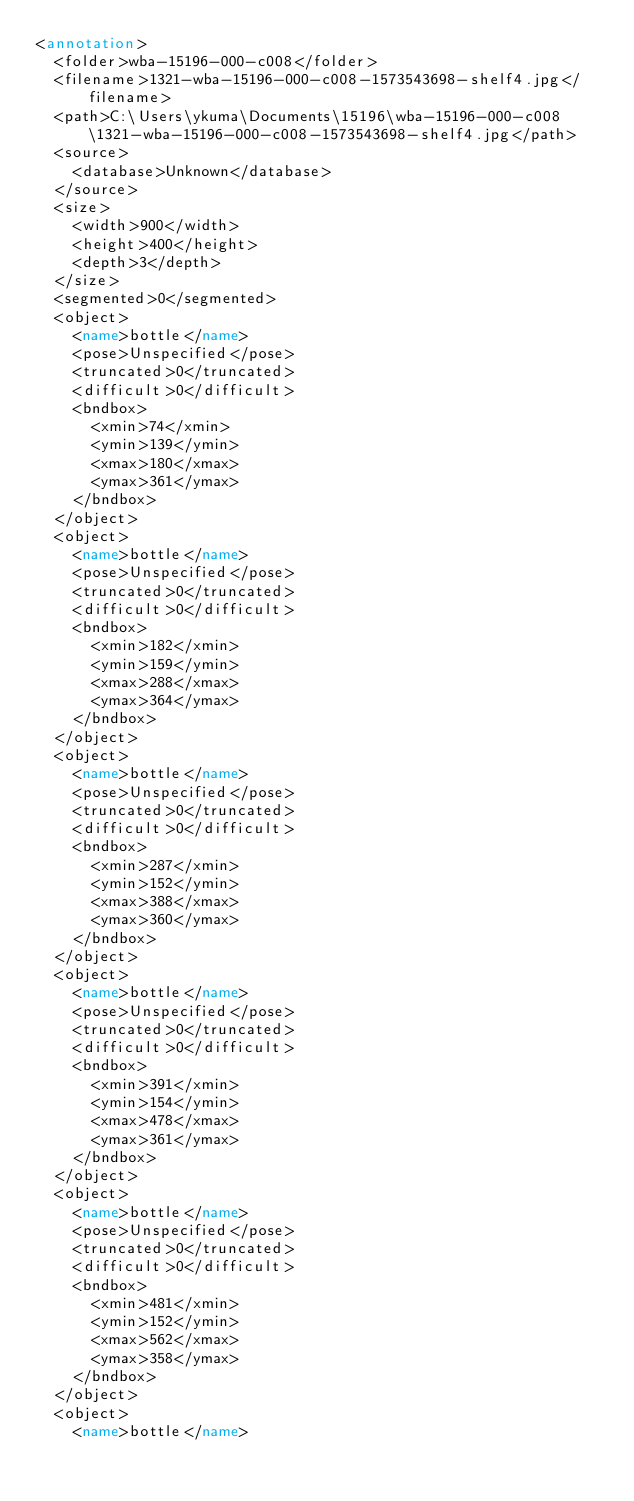Convert code to text. <code><loc_0><loc_0><loc_500><loc_500><_XML_><annotation>
	<folder>wba-15196-000-c008</folder>
	<filename>1321-wba-15196-000-c008-1573543698-shelf4.jpg</filename>
	<path>C:\Users\ykuma\Documents\15196\wba-15196-000-c008\1321-wba-15196-000-c008-1573543698-shelf4.jpg</path>
	<source>
		<database>Unknown</database>
	</source>
	<size>
		<width>900</width>
		<height>400</height>
		<depth>3</depth>
	</size>
	<segmented>0</segmented>
	<object>
		<name>bottle</name>
		<pose>Unspecified</pose>
		<truncated>0</truncated>
		<difficult>0</difficult>
		<bndbox>
			<xmin>74</xmin>
			<ymin>139</ymin>
			<xmax>180</xmax>
			<ymax>361</ymax>
		</bndbox>
	</object>
	<object>
		<name>bottle</name>
		<pose>Unspecified</pose>
		<truncated>0</truncated>
		<difficult>0</difficult>
		<bndbox>
			<xmin>182</xmin>
			<ymin>159</ymin>
			<xmax>288</xmax>
			<ymax>364</ymax>
		</bndbox>
	</object>
	<object>
		<name>bottle</name>
		<pose>Unspecified</pose>
		<truncated>0</truncated>
		<difficult>0</difficult>
		<bndbox>
			<xmin>287</xmin>
			<ymin>152</ymin>
			<xmax>388</xmax>
			<ymax>360</ymax>
		</bndbox>
	</object>
	<object>
		<name>bottle</name>
		<pose>Unspecified</pose>
		<truncated>0</truncated>
		<difficult>0</difficult>
		<bndbox>
			<xmin>391</xmin>
			<ymin>154</ymin>
			<xmax>478</xmax>
			<ymax>361</ymax>
		</bndbox>
	</object>
	<object>
		<name>bottle</name>
		<pose>Unspecified</pose>
		<truncated>0</truncated>
		<difficult>0</difficult>
		<bndbox>
			<xmin>481</xmin>
			<ymin>152</ymin>
			<xmax>562</xmax>
			<ymax>358</ymax>
		</bndbox>
	</object>
	<object>
		<name>bottle</name></code> 